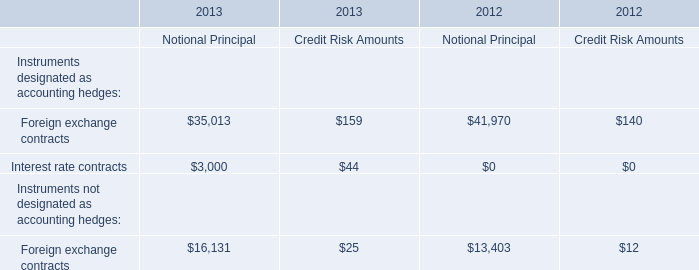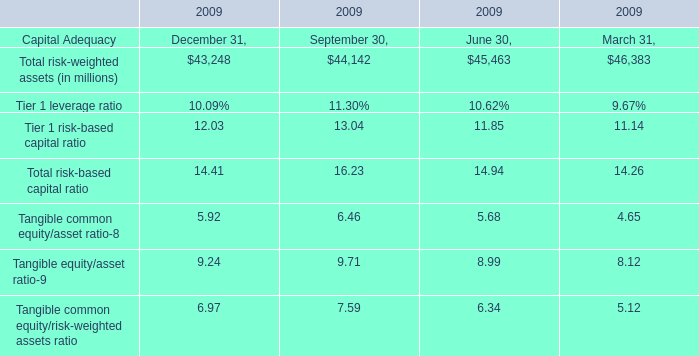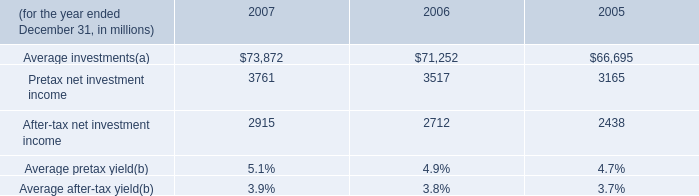Just as the chart shows,at the time when the Total risk-based capital ratio is 16.23%, what's the Tangible common equity/asset ratio? (in %) 
Answer: 6.46. 